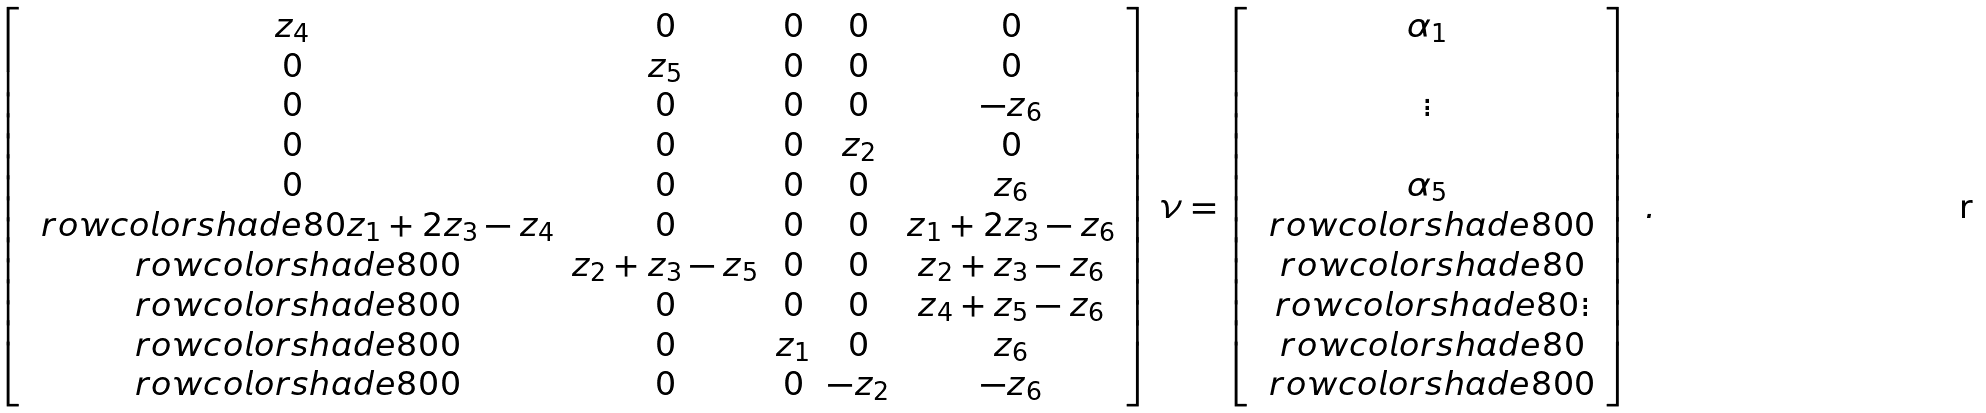<formula> <loc_0><loc_0><loc_500><loc_500>\left [ \begin{array} { c c c c c } z _ { 4 } & 0 & 0 & 0 & 0 \\ 0 & z _ { 5 } & 0 & 0 & 0 \\ 0 & 0 & 0 & 0 & - z _ { 6 } \\ 0 & 0 & 0 & z _ { 2 } & 0 \\ 0 & 0 & 0 & 0 & z _ { 6 } \\ \ r o w c o l o r { s h a d e 8 0 } z _ { 1 } + 2 z _ { 3 } - z _ { 4 } & 0 & 0 & 0 & z _ { 1 } + 2 z _ { 3 } - z _ { 6 } \\ \ r o w c o l o r { s h a d e 8 0 } 0 & z _ { 2 } + z _ { 3 } - z _ { 5 } & 0 & 0 & z _ { 2 } + z _ { 3 } - z _ { 6 } \\ \ r o w c o l o r { s h a d e 8 0 } 0 & 0 & 0 & 0 & z _ { 4 } + z _ { 5 } - z _ { 6 } \\ \ r o w c o l o r { s h a d e 8 0 } 0 & 0 & z _ { 1 } & 0 & z _ { 6 } \\ \ r o w c o l o r { s h a d e 8 0 } 0 & 0 & 0 & - z _ { 2 } & - z _ { 6 } \end{array} \right ] \, \nu = \left [ \begin{array} { c } \alpha _ { 1 } \\ \\ \vdots \\ \\ \alpha _ { 5 } \\ \ r o w c o l o r { s h a d e 8 0 } 0 \\ \ r o w c o l o r { s h a d e 8 0 } \\ \ r o w c o l o r { s h a d e 8 0 } \vdots \\ \ r o w c o l o r { s h a d e 8 0 } \\ \ r o w c o l o r { s h a d e 8 0 } 0 \end{array} \right ] \ .</formula> 